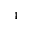Convert formula to latex. <formula><loc_0><loc_0><loc_500><loc_500>_ { 4 }</formula> 